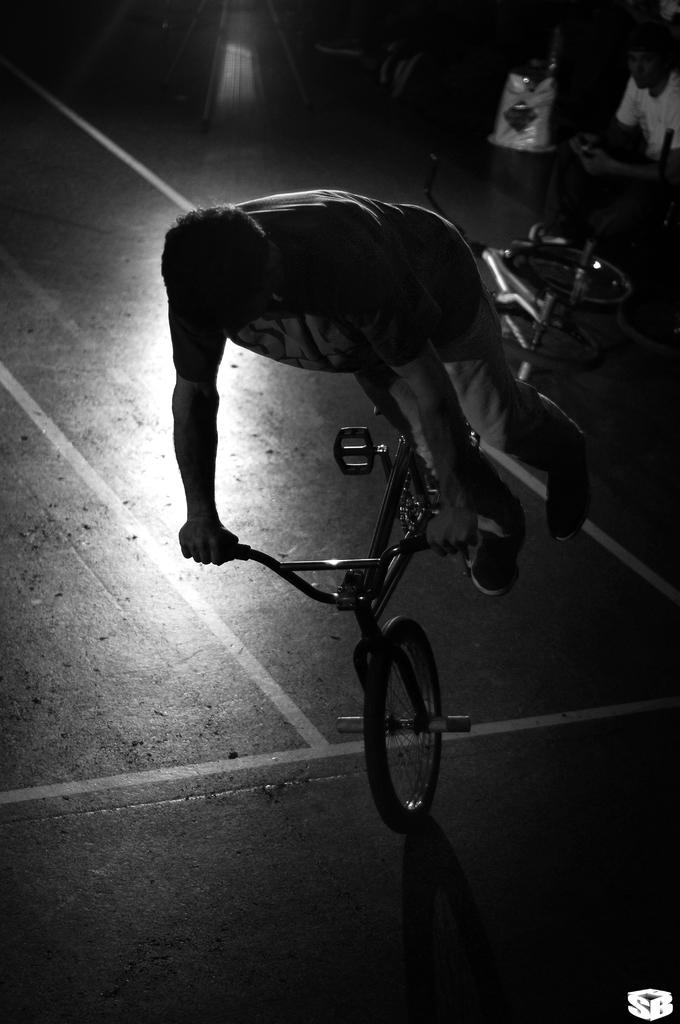What is the main subject of the image? There is a person riding a bicycle in the image. What can be seen beneath the person riding the bicycle? The floor is visible in the image. Are there any other bicycles in the image? Yes, there is another bicycle in the image. Can you describe the human visible in the right corner of the image? There is a human visible in the right corner of the image, but no specific details are provided. What type of industry is depicted in the cellar of the image? There is no mention of an industry or a cellar in the image. 